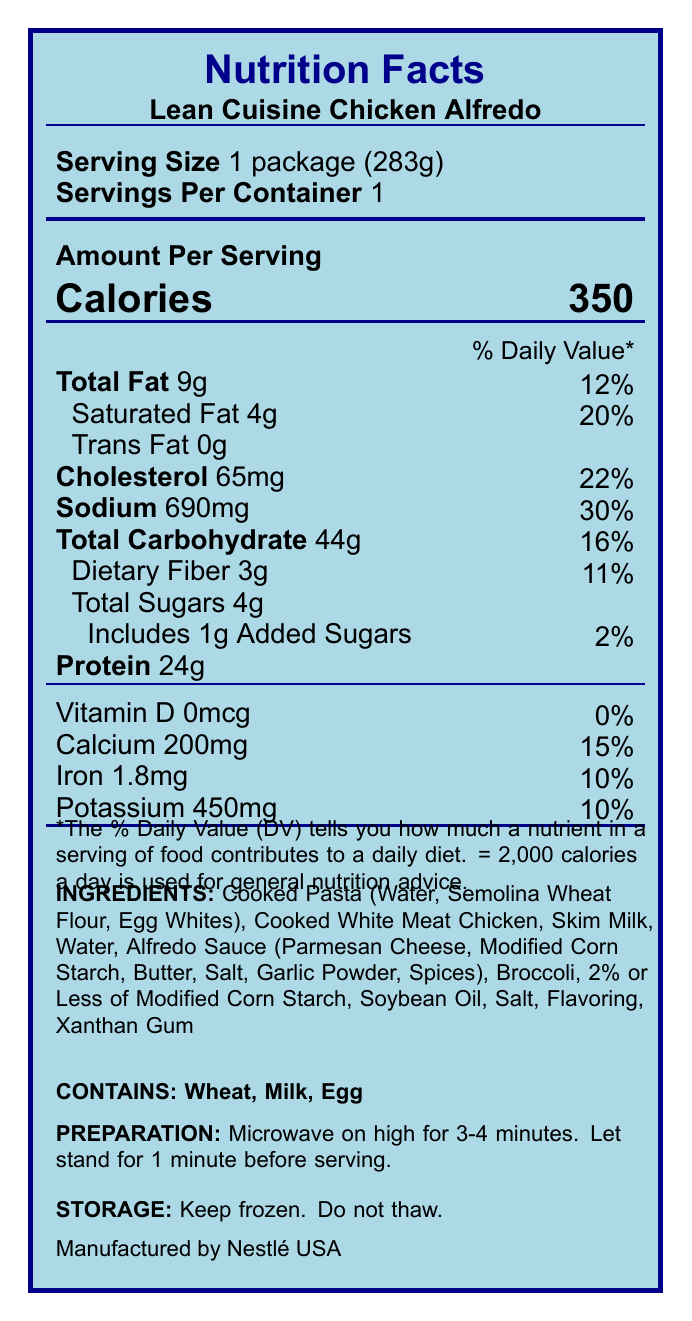What is the serving size of the Lean Cuisine Chicken Alfredo? The serving size is specified as "1 package (283g)" on the label.
Answer: 1 package (283g) How many calories are in one serving of Lean Cuisine Chicken Alfredo? The label states there are 350 calories per serving.
Answer: 350 calories What percentage of the Daily Value does the sodium content represent? The label shows that the sodium content is 690mg, which corresponds to 30% of the Daily Value.
Answer: 30% How much protein is present in the Lean Cuisine Chicken Alfredo? The label clearly states that the meal contains 24g of protein.
Answer: 24g Name one allergen contained in the Lean Cuisine Chicken Alfredo. The label mentions that the product contains wheat, milk, and egg.
Answer: Wheat Which nutrient has the highest percentage of the Daily Value per serving? 
   A. Saturated Fat 
   B. Dietary Fiber 
   C. Sodium 
   D. Cholesterol The sodium content is 30% of the Daily Value, which is higher compared with other listed nutrients.
Answer: C. Sodium What is the total carbohydrate content in one serving? The label indicates that the total carbohydrate content is 44g per serving.
Answer: 44g How long should you microwave the meal according to preparation instructions? 
    1. 2-3 minutes
    2. 3-4 minutes 
    3. 4-5 minutes The preparation instructions specify to microwave on high for 3-4 minutes.
Answer: 2. 3-4 minutes Is there any trans fat in the Lean Cuisine Chicken Alfredo? The label states that the trans fat content is 0g.
Answer: No Summarize the main nutritional information contained in the document. The label provides key nutritional data including calorie content, macronutrients, percentages of Daily Value for various nutrients, and preparation and allergen information.
Answer: The Lean Cuisine Chicken Alfredo has serving size of 283g with 350 calories. It contains 9g of fat, 44g of carbohydrates, and 24g of protein. The sodium content is relatively high at 30% of the Daily Value. The meal also provides 15% of the Daily Value for calcium and smaller percentages for iron and potassium. The product includes wheat, milk, and egg as allergens, and it should be microwaved for 3-4 minutes before consumption. What are the ingredients of the Alfredo Sauce in this meal? The label lists these specific ingredients under Alfredo Sauce.
Answer: Parmesan Cheese, Modified Corn Starch, Butter, Salt, Garlic Powder, Spices How much vitamin D is in one serving of Lean Cuisine Chicken Alfredo? The label indicates that the vitamin D content is 0mcg with 0% of the Daily Value.
Answer: 0mcg What is the manufacturer's name for this product? The label clearly states that the product is manufactured by Nestlé USA.
Answer: Nestlé USA What is the exact amount of dietary fiber present in one serving of Lean Cuisine Chicken Alfredo? The label specifies that the dietary fiber content is 3g per serving.
Answer: 3g Does the product contain soy? The document does not mention soy in the ingredients or allergens section.
Answer: Not enough information 